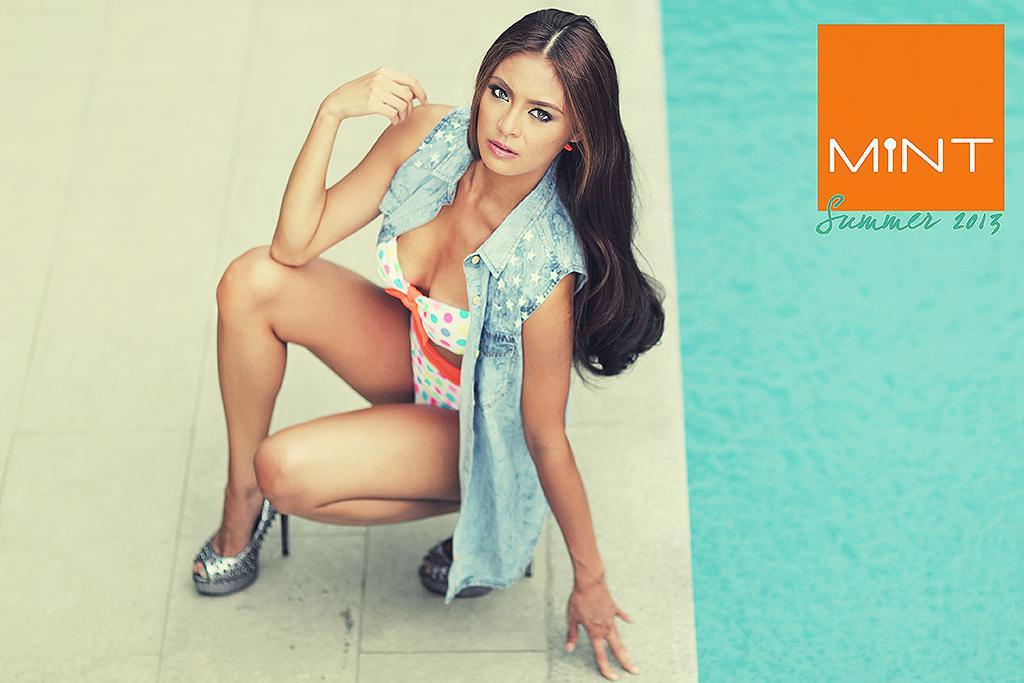What is featured in the image besides the woman? There is a poster in the image. What is the woman doing in the image? The woman is in a squat position and giving a pose. Where is the text located in the image? The text is in the top right corner of the image. How many birds are flying in the image? There are no birds present in the image. What type of sail is visible in the image? There is no sail present in the image. 